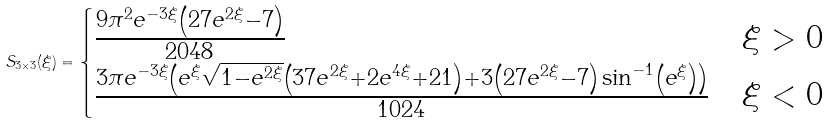<formula> <loc_0><loc_0><loc_500><loc_500>S _ { 3 \times 3 } ( \xi ) = \begin{cases} \frac { 9 \pi ^ { 2 } e ^ { - 3 \xi } \left ( 2 7 e ^ { 2 \xi } - 7 \right ) } { 2 0 4 8 } & \xi > 0 \\ \frac { 3 \pi e ^ { - 3 \xi } \left ( e ^ { \xi } \sqrt { 1 - e ^ { 2 \xi } } \left ( 3 7 e ^ { 2 \xi } + 2 e ^ { 4 \xi } + 2 1 \right ) + 3 \left ( 2 7 e ^ { 2 \xi } - 7 \right ) \sin ^ { - 1 } \left ( e ^ { \xi } \right ) \right ) } { 1 0 2 4 } & \xi < 0 \end{cases}</formula> 